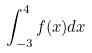<formula> <loc_0><loc_0><loc_500><loc_500>\int _ { - 3 } ^ { 4 } f ( x ) d x</formula> 